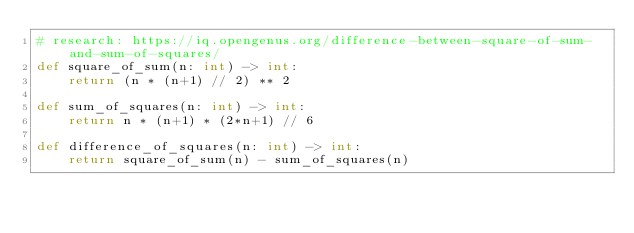<code> <loc_0><loc_0><loc_500><loc_500><_Python_># research: https://iq.opengenus.org/difference-between-square-of-sum-and-sum-of-squares/
def square_of_sum(n: int) -> int:
    return (n * (n+1) // 2) ** 2

def sum_of_squares(n: int) -> int:
    return n * (n+1) * (2*n+1) // 6

def difference_of_squares(n: int) -> int:
    return square_of_sum(n) - sum_of_squares(n)
</code> 